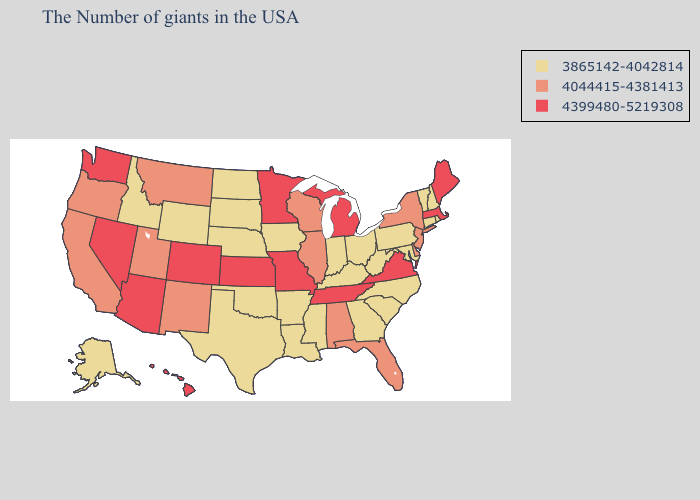Among the states that border Mississippi , which have the highest value?
Answer briefly. Tennessee. Does Florida have the same value as West Virginia?
Quick response, please. No. Does South Dakota have the highest value in the MidWest?
Be succinct. No. What is the value of Michigan?
Answer briefly. 4399480-5219308. Does Wyoming have the lowest value in the USA?
Answer briefly. Yes. Does Minnesota have a lower value than Maryland?
Be succinct. No. Does Alaska have the highest value in the USA?
Concise answer only. No. Among the states that border Maryland , which have the highest value?
Be succinct. Virginia. Name the states that have a value in the range 4044415-4381413?
Answer briefly. New York, New Jersey, Delaware, Florida, Alabama, Wisconsin, Illinois, New Mexico, Utah, Montana, California, Oregon. Which states have the lowest value in the Northeast?
Keep it brief. Rhode Island, New Hampshire, Vermont, Connecticut, Pennsylvania. What is the value of California?
Short answer required. 4044415-4381413. What is the value of New Hampshire?
Quick response, please. 3865142-4042814. What is the lowest value in the USA?
Answer briefly. 3865142-4042814. What is the highest value in states that border Ohio?
Be succinct. 4399480-5219308. Does the map have missing data?
Be succinct. No. 